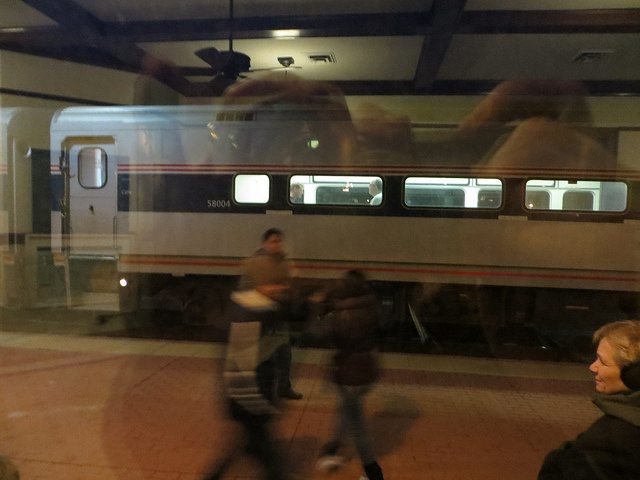Describe the objects in this image and their specific colors. I can see train in black and gray tones, people in black, maroon, and brown tones, people in black, maroon, and gray tones, people in black, maroon, and brown tones, and people in black, darkgray, and gray tones in this image. 